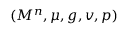<formula> <loc_0><loc_0><loc_500><loc_500>( M ^ { n } , \mu , g , v , p )</formula> 